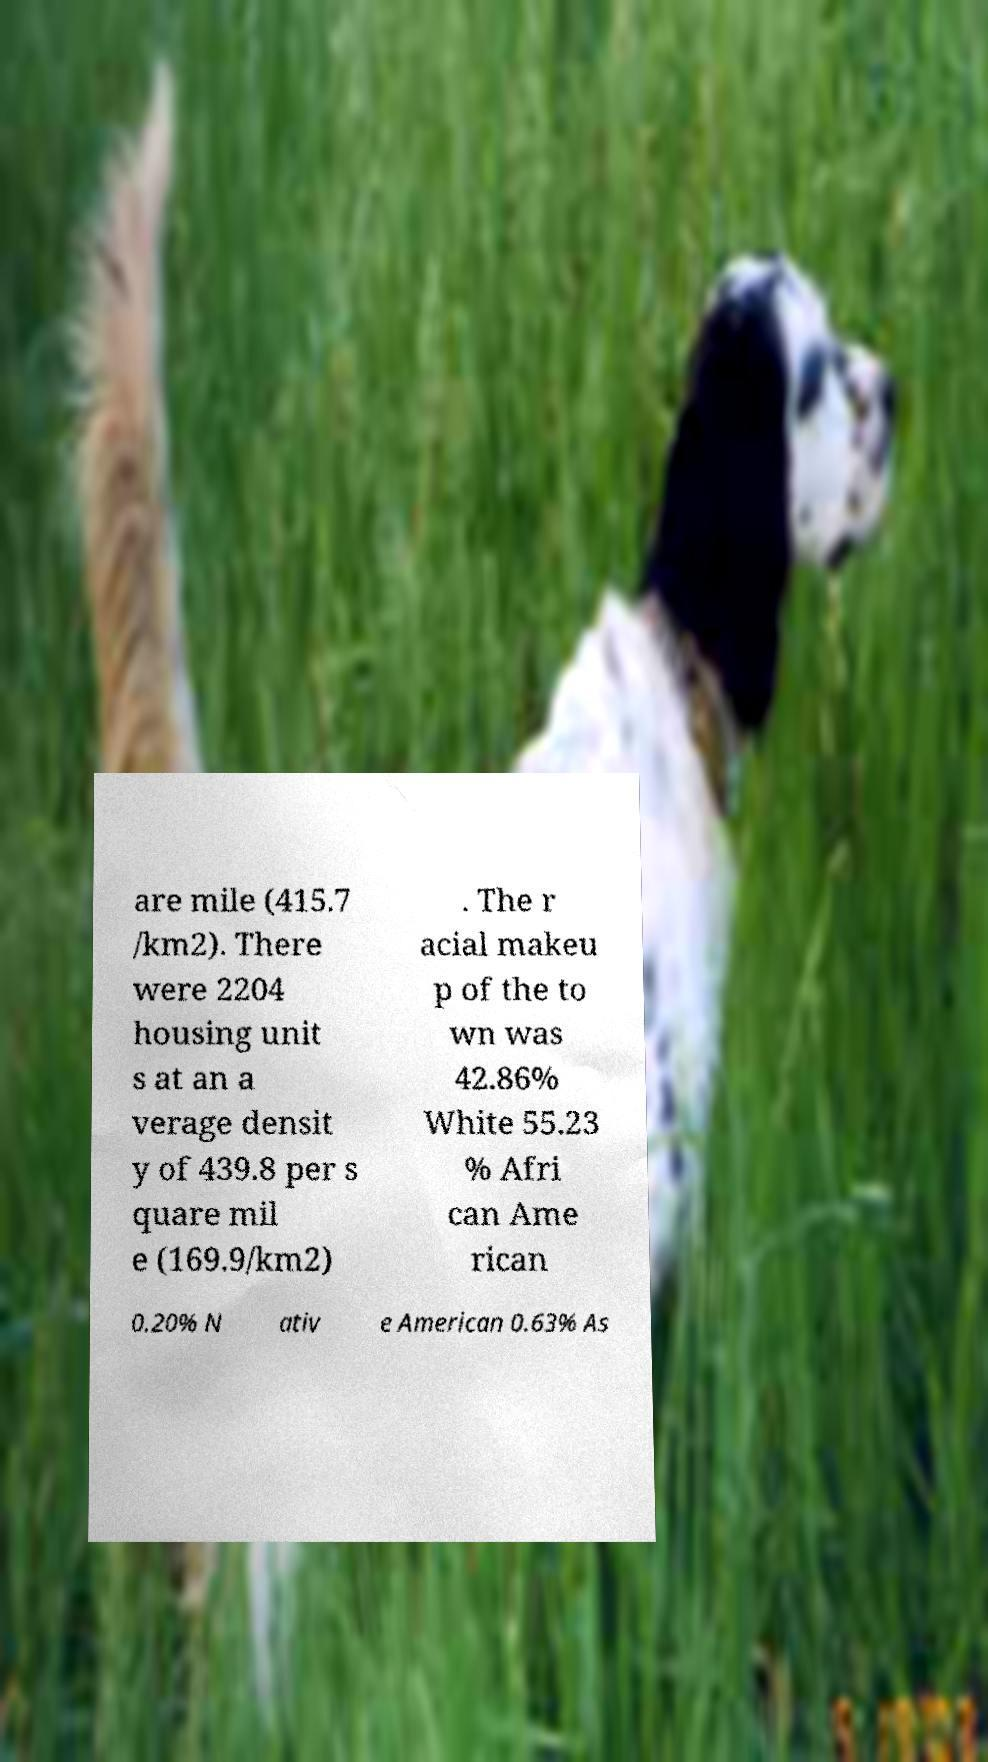There's text embedded in this image that I need extracted. Can you transcribe it verbatim? are mile (415.7 /km2). There were 2204 housing unit s at an a verage densit y of 439.8 per s quare mil e (169.9/km2) . The r acial makeu p of the to wn was 42.86% White 55.23 % Afri can Ame rican 0.20% N ativ e American 0.63% As 